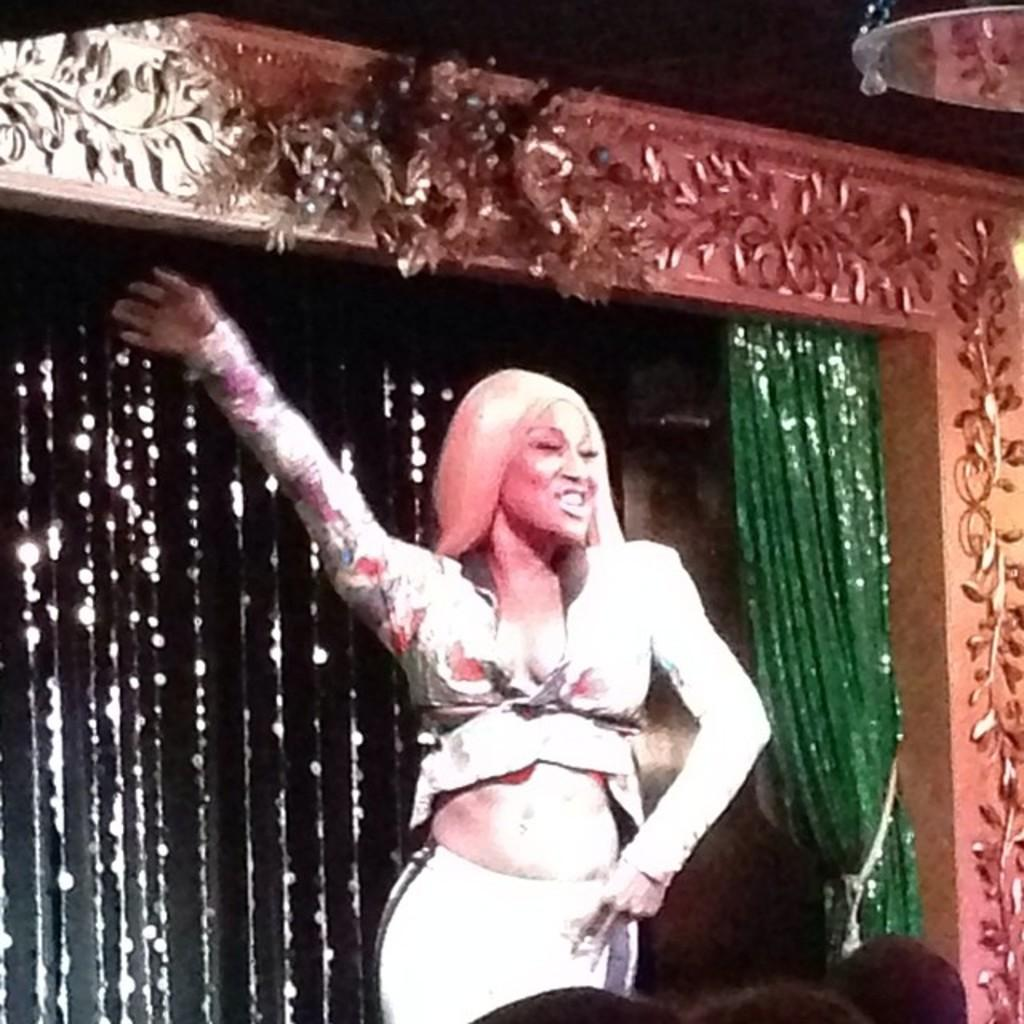Who is the main subject in the image? There is a woman in the image. What is the woman doing in the image? The woman is dancing on a stage. What is the color of the curtain in the background? There is a green color curtain in the background. What else can be seen in the image besides the woman and the curtain? There are decorative items in the image. What type of poison is the woman using to enhance her dance performance in the image? There is no poison present in the image, and the woman is not using any substance to enhance her dance performance. 